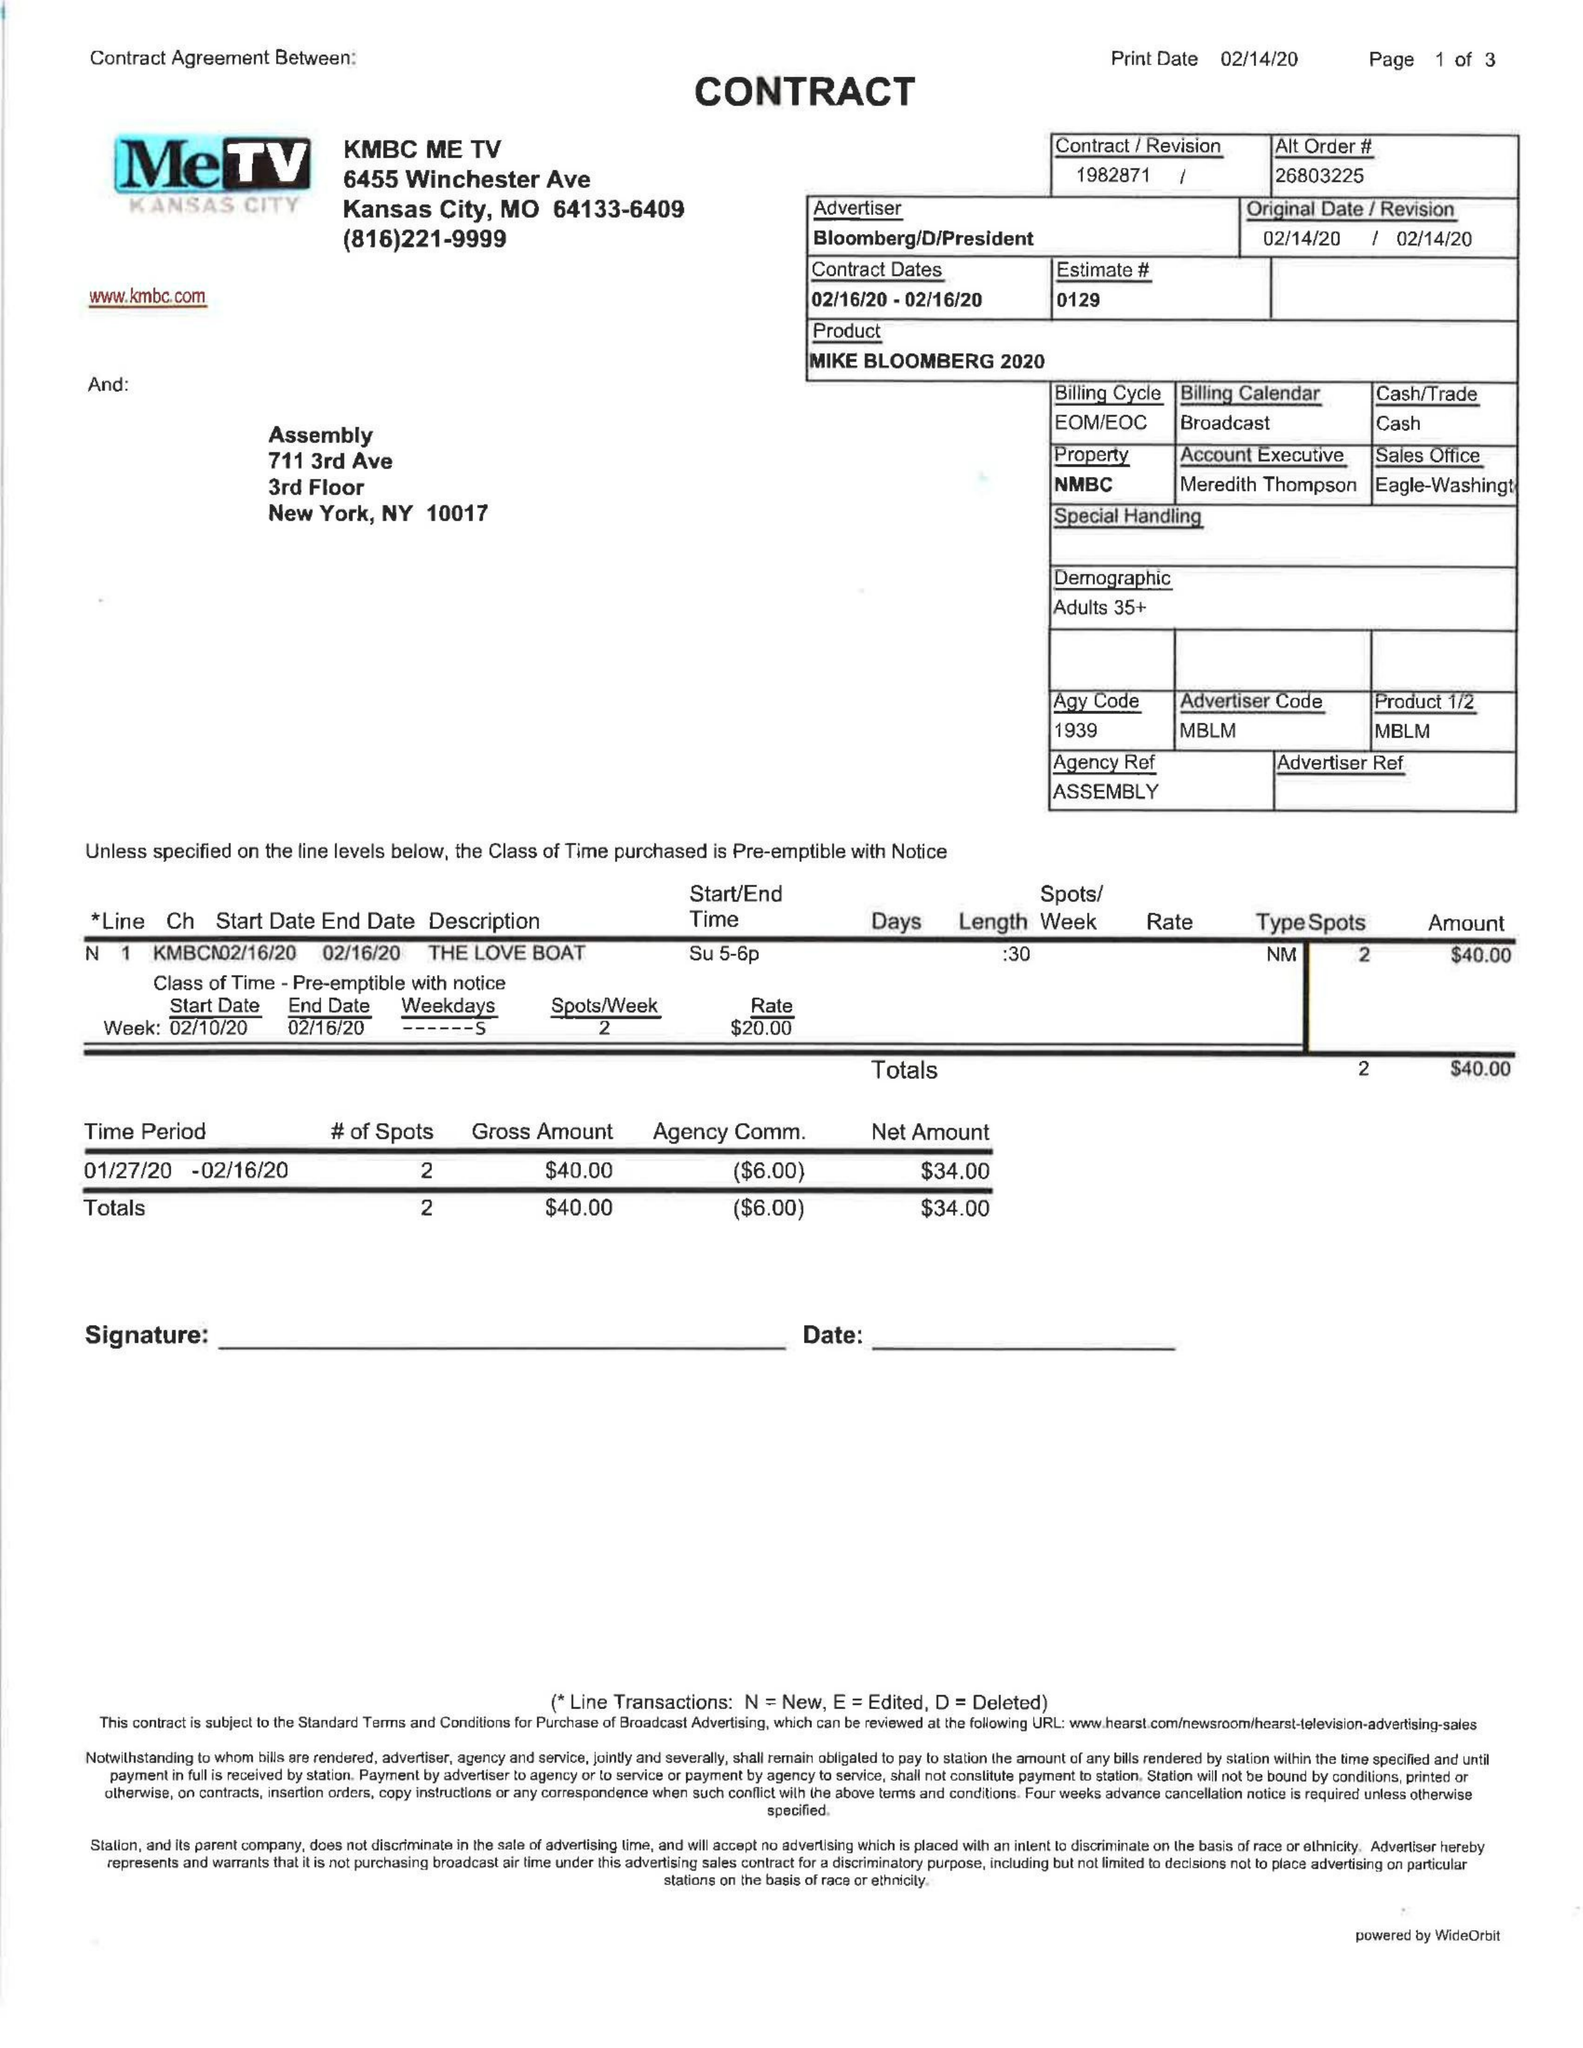What is the value for the contract_num?
Answer the question using a single word or phrase. 1982871 